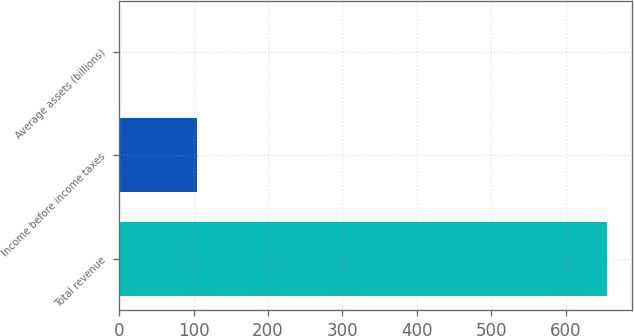<chart> <loc_0><loc_0><loc_500><loc_500><bar_chart><fcel>Total revenue<fcel>Income before income taxes<fcel>Average assets (billions)<nl><fcel>656<fcel>104<fcel>1.2<nl></chart> 